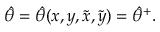<formula> <loc_0><loc_0><loc_500><loc_500>\hat { \theta } = \hat { \theta } ( x , y , \tilde { x } , \tilde { y } ) = \hat { \theta } ^ { + } .</formula> 